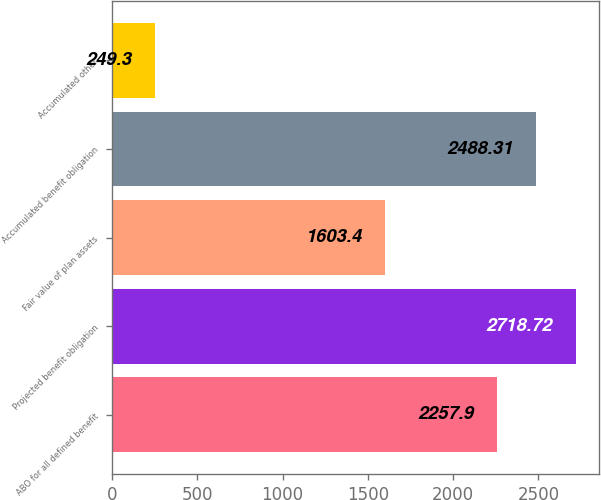<chart> <loc_0><loc_0><loc_500><loc_500><bar_chart><fcel>ABO for all defined benefit<fcel>Projected benefit obligation<fcel>Fair value of plan assets<fcel>Accumulated benefit obligation<fcel>Accumulated other<nl><fcel>2257.9<fcel>2718.72<fcel>1603.4<fcel>2488.31<fcel>249.3<nl></chart> 